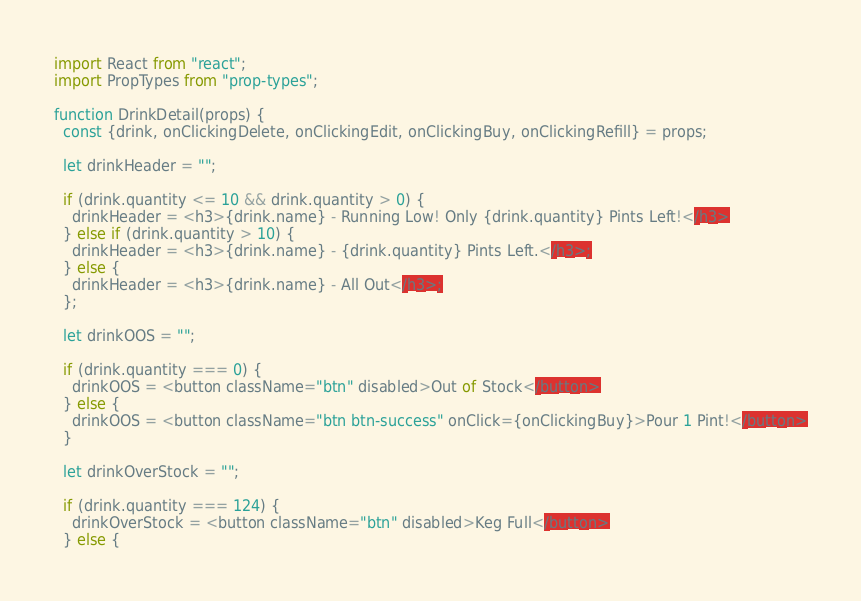<code> <loc_0><loc_0><loc_500><loc_500><_JavaScript_>import React from "react";
import PropTypes from "prop-types";

function DrinkDetail(props) {
  const {drink, onClickingDelete, onClickingEdit, onClickingBuy, onClickingRefill} = props;

  let drinkHeader = "";

  if (drink.quantity <= 10 && drink.quantity > 0) {
    drinkHeader = <h3>{drink.name} - Running Low! Only {drink.quantity} Pints Left!</h3>
  } else if (drink.quantity > 10) {
    drinkHeader = <h3>{drink.name} - {drink.quantity} Pints Left.</h3>;
  } else {
    drinkHeader = <h3>{drink.name} - All Out</h3>;
  };

  let drinkOOS = "";

  if (drink.quantity === 0) {
    drinkOOS = <button className="btn" disabled>Out of Stock</button>
  } else {
    drinkOOS = <button className="btn btn-success" onClick={onClickingBuy}>Pour 1 Pint!</button>
  }

  let drinkOverStock = "";

  if (drink.quantity === 124) {
    drinkOverStock = <button className="btn" disabled>Keg Full</button>
  } else {</code> 